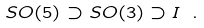<formula> <loc_0><loc_0><loc_500><loc_500>S O ( 5 ) \supset S O ( 3 ) \supset I \ .</formula> 